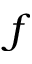Convert formula to latex. <formula><loc_0><loc_0><loc_500><loc_500>f</formula> 